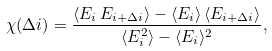Convert formula to latex. <formula><loc_0><loc_0><loc_500><loc_500>\chi ( \Delta i ) = \frac { \langle E _ { i } \, E _ { i + \Delta i } \rangle - \langle E _ { i } \rangle \, \langle E _ { i + \Delta i } \rangle } { \langle E _ { i } ^ { 2 } \rangle - \langle E _ { i } \rangle ^ { 2 } } ,</formula> 